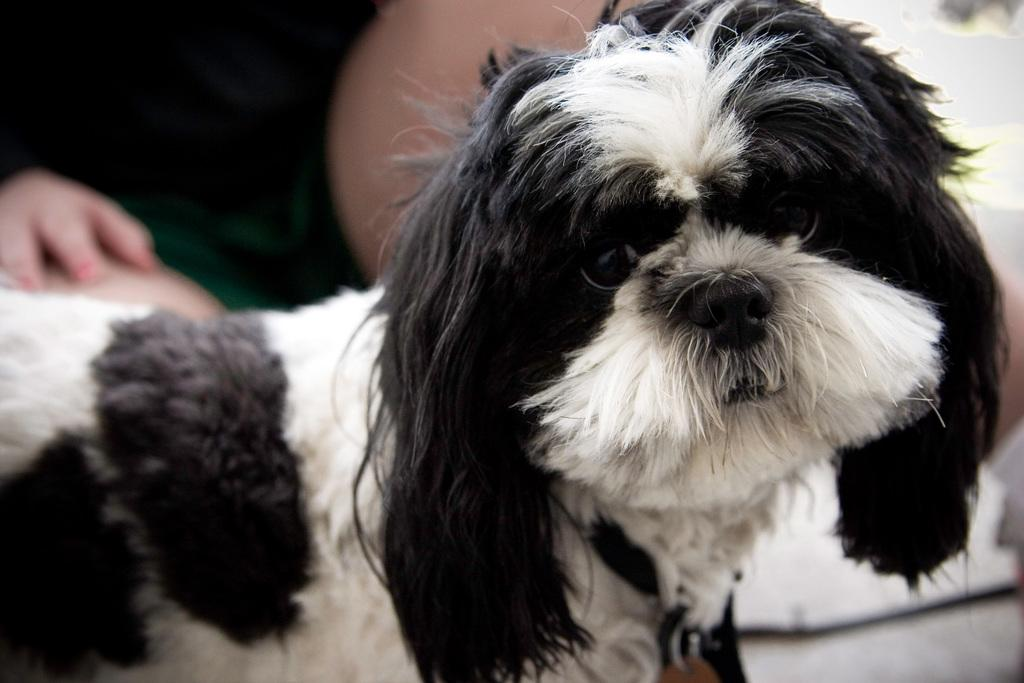What type of animal is in the picture? There is a dog in the picture. Who or what else is in the picture? There is a person in the picture. What language is the dog speaking in the picture? Dogs do not speak human languages, so it is not possible to determine what language the dog might be speaking in the image. 